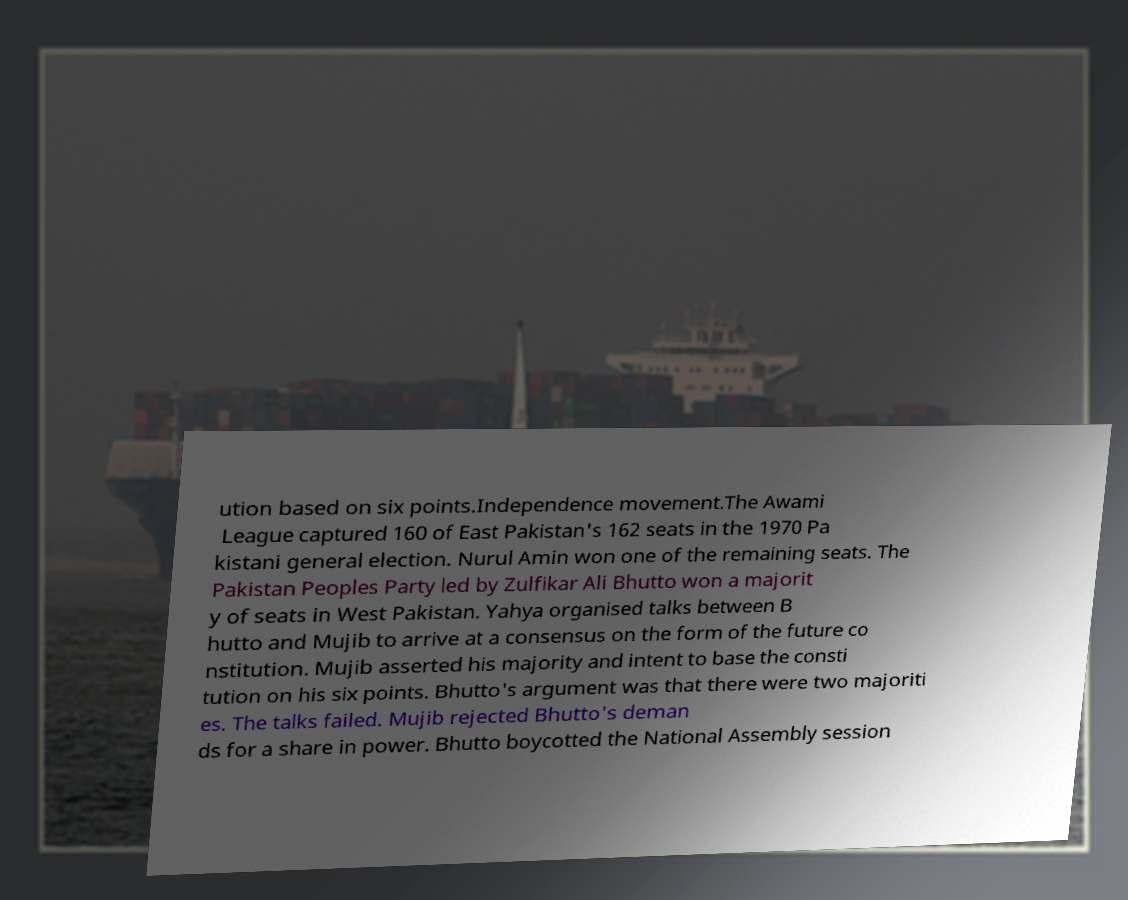I need the written content from this picture converted into text. Can you do that? ution based on six points.Independence movement.The Awami League captured 160 of East Pakistan's 162 seats in the 1970 Pa kistani general election. Nurul Amin won one of the remaining seats. The Pakistan Peoples Party led by Zulfikar Ali Bhutto won a majorit y of seats in West Pakistan. Yahya organised talks between B hutto and Mujib to arrive at a consensus on the form of the future co nstitution. Mujib asserted his majority and intent to base the consti tution on his six points. Bhutto's argument was that there were two majoriti es. The talks failed. Mujib rejected Bhutto's deman ds for a share in power. Bhutto boycotted the National Assembly session 